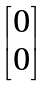Convert formula to latex. <formula><loc_0><loc_0><loc_500><loc_500>\begin{bmatrix} 0 \\ 0 \\ \end{bmatrix}</formula> 